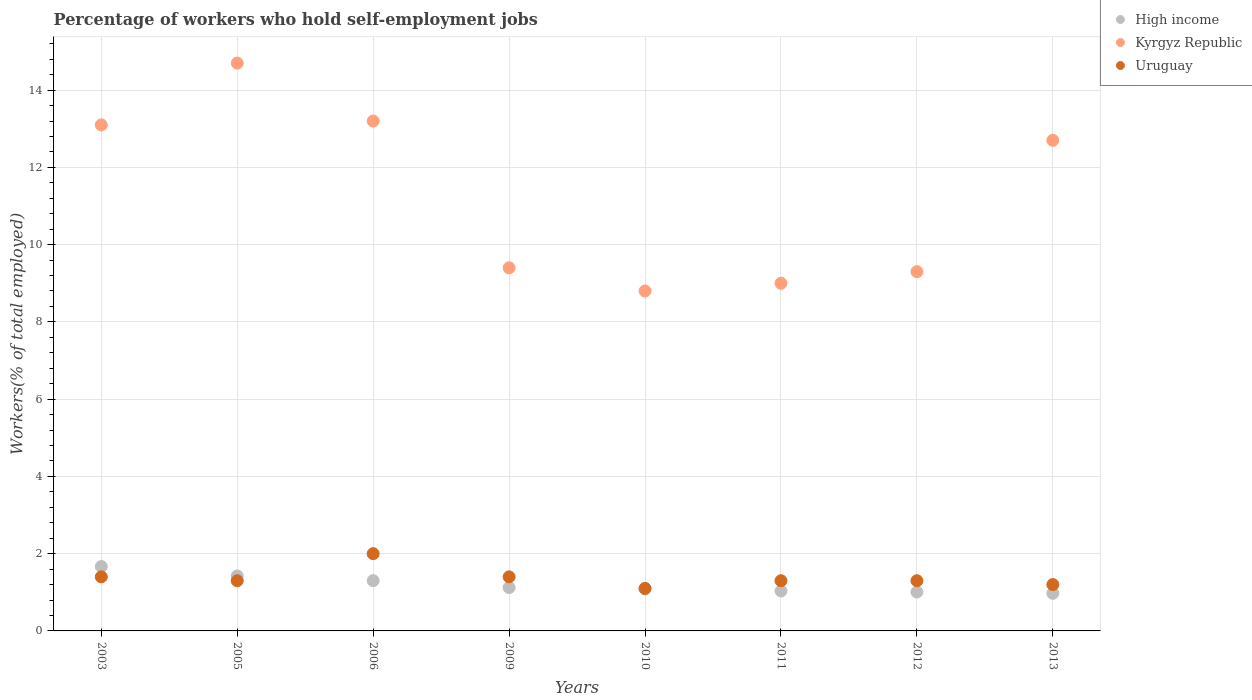Is the number of dotlines equal to the number of legend labels?
Keep it short and to the point. Yes. What is the percentage of self-employed workers in Uruguay in 2003?
Offer a very short reply. 1.4. Across all years, what is the minimum percentage of self-employed workers in Uruguay?
Ensure brevity in your answer.  1.1. In which year was the percentage of self-employed workers in Uruguay minimum?
Provide a succinct answer. 2010. What is the total percentage of self-employed workers in High income in the graph?
Your answer should be very brief. 9.62. What is the difference between the percentage of self-employed workers in Uruguay in 2010 and that in 2013?
Your answer should be very brief. -0.1. What is the difference between the percentage of self-employed workers in High income in 2013 and the percentage of self-employed workers in Kyrgyz Republic in 2010?
Keep it short and to the point. -7.83. What is the average percentage of self-employed workers in High income per year?
Give a very brief answer. 1.2. In the year 2011, what is the difference between the percentage of self-employed workers in High income and percentage of self-employed workers in Uruguay?
Provide a succinct answer. -0.27. What is the ratio of the percentage of self-employed workers in Kyrgyz Republic in 2010 to that in 2011?
Your answer should be compact. 0.98. Is the percentage of self-employed workers in High income in 2005 less than that in 2012?
Provide a short and direct response. No. What is the difference between the highest and the second highest percentage of self-employed workers in Kyrgyz Republic?
Make the answer very short. 1.5. What is the difference between the highest and the lowest percentage of self-employed workers in High income?
Provide a succinct answer. 0.69. In how many years, is the percentage of self-employed workers in Kyrgyz Republic greater than the average percentage of self-employed workers in Kyrgyz Republic taken over all years?
Provide a succinct answer. 4. Is the sum of the percentage of self-employed workers in High income in 2005 and 2012 greater than the maximum percentage of self-employed workers in Uruguay across all years?
Ensure brevity in your answer.  Yes. Is it the case that in every year, the sum of the percentage of self-employed workers in Uruguay and percentage of self-employed workers in High income  is greater than the percentage of self-employed workers in Kyrgyz Republic?
Your response must be concise. No. Does the percentage of self-employed workers in Kyrgyz Republic monotonically increase over the years?
Your answer should be very brief. No. How many dotlines are there?
Offer a very short reply. 3. What is the difference between two consecutive major ticks on the Y-axis?
Keep it short and to the point. 2. Are the values on the major ticks of Y-axis written in scientific E-notation?
Provide a short and direct response. No. Where does the legend appear in the graph?
Keep it short and to the point. Top right. How many legend labels are there?
Ensure brevity in your answer.  3. How are the legend labels stacked?
Keep it short and to the point. Vertical. What is the title of the graph?
Give a very brief answer. Percentage of workers who hold self-employment jobs. What is the label or title of the Y-axis?
Offer a terse response. Workers(% of total employed). What is the Workers(% of total employed) in High income in 2003?
Provide a succinct answer. 1.67. What is the Workers(% of total employed) of Kyrgyz Republic in 2003?
Your response must be concise. 13.1. What is the Workers(% of total employed) of Uruguay in 2003?
Provide a succinct answer. 1.4. What is the Workers(% of total employed) of High income in 2005?
Your answer should be compact. 1.42. What is the Workers(% of total employed) of Kyrgyz Republic in 2005?
Give a very brief answer. 14.7. What is the Workers(% of total employed) in Uruguay in 2005?
Offer a very short reply. 1.3. What is the Workers(% of total employed) of High income in 2006?
Offer a terse response. 1.3. What is the Workers(% of total employed) of Kyrgyz Republic in 2006?
Give a very brief answer. 13.2. What is the Workers(% of total employed) of Uruguay in 2006?
Your answer should be compact. 2. What is the Workers(% of total employed) in High income in 2009?
Give a very brief answer. 1.12. What is the Workers(% of total employed) in Kyrgyz Republic in 2009?
Provide a short and direct response. 9.4. What is the Workers(% of total employed) in Uruguay in 2009?
Make the answer very short. 1.4. What is the Workers(% of total employed) in High income in 2010?
Your response must be concise. 1.09. What is the Workers(% of total employed) in Kyrgyz Republic in 2010?
Ensure brevity in your answer.  8.8. What is the Workers(% of total employed) in Uruguay in 2010?
Make the answer very short. 1.1. What is the Workers(% of total employed) of High income in 2011?
Your response must be concise. 1.03. What is the Workers(% of total employed) in Uruguay in 2011?
Give a very brief answer. 1.3. What is the Workers(% of total employed) of High income in 2012?
Offer a terse response. 1.01. What is the Workers(% of total employed) in Kyrgyz Republic in 2012?
Keep it short and to the point. 9.3. What is the Workers(% of total employed) in Uruguay in 2012?
Provide a short and direct response. 1.3. What is the Workers(% of total employed) of High income in 2013?
Make the answer very short. 0.97. What is the Workers(% of total employed) in Kyrgyz Republic in 2013?
Offer a very short reply. 12.7. What is the Workers(% of total employed) of Uruguay in 2013?
Provide a succinct answer. 1.2. Across all years, what is the maximum Workers(% of total employed) of High income?
Keep it short and to the point. 1.67. Across all years, what is the maximum Workers(% of total employed) of Kyrgyz Republic?
Provide a short and direct response. 14.7. Across all years, what is the maximum Workers(% of total employed) of Uruguay?
Your answer should be compact. 2. Across all years, what is the minimum Workers(% of total employed) of High income?
Ensure brevity in your answer.  0.97. Across all years, what is the minimum Workers(% of total employed) in Kyrgyz Republic?
Your answer should be very brief. 8.8. Across all years, what is the minimum Workers(% of total employed) of Uruguay?
Your response must be concise. 1.1. What is the total Workers(% of total employed) of High income in the graph?
Keep it short and to the point. 9.62. What is the total Workers(% of total employed) in Kyrgyz Republic in the graph?
Ensure brevity in your answer.  90.2. What is the difference between the Workers(% of total employed) in High income in 2003 and that in 2005?
Make the answer very short. 0.24. What is the difference between the Workers(% of total employed) in Kyrgyz Republic in 2003 and that in 2005?
Your answer should be very brief. -1.6. What is the difference between the Workers(% of total employed) in Uruguay in 2003 and that in 2005?
Offer a very short reply. 0.1. What is the difference between the Workers(% of total employed) in High income in 2003 and that in 2006?
Provide a succinct answer. 0.37. What is the difference between the Workers(% of total employed) of Kyrgyz Republic in 2003 and that in 2006?
Offer a very short reply. -0.1. What is the difference between the Workers(% of total employed) of Uruguay in 2003 and that in 2006?
Your answer should be very brief. -0.6. What is the difference between the Workers(% of total employed) of High income in 2003 and that in 2009?
Your answer should be compact. 0.55. What is the difference between the Workers(% of total employed) of Kyrgyz Republic in 2003 and that in 2009?
Provide a short and direct response. 3.7. What is the difference between the Workers(% of total employed) in High income in 2003 and that in 2010?
Keep it short and to the point. 0.58. What is the difference between the Workers(% of total employed) of Kyrgyz Republic in 2003 and that in 2010?
Ensure brevity in your answer.  4.3. What is the difference between the Workers(% of total employed) of Uruguay in 2003 and that in 2010?
Give a very brief answer. 0.3. What is the difference between the Workers(% of total employed) of High income in 2003 and that in 2011?
Ensure brevity in your answer.  0.63. What is the difference between the Workers(% of total employed) of Kyrgyz Republic in 2003 and that in 2011?
Provide a succinct answer. 4.1. What is the difference between the Workers(% of total employed) in High income in 2003 and that in 2012?
Provide a short and direct response. 0.66. What is the difference between the Workers(% of total employed) in Kyrgyz Republic in 2003 and that in 2012?
Offer a terse response. 3.8. What is the difference between the Workers(% of total employed) of Uruguay in 2003 and that in 2012?
Provide a short and direct response. 0.1. What is the difference between the Workers(% of total employed) of High income in 2003 and that in 2013?
Keep it short and to the point. 0.69. What is the difference between the Workers(% of total employed) in Kyrgyz Republic in 2003 and that in 2013?
Offer a very short reply. 0.4. What is the difference between the Workers(% of total employed) in High income in 2005 and that in 2006?
Give a very brief answer. 0.12. What is the difference between the Workers(% of total employed) in High income in 2005 and that in 2009?
Give a very brief answer. 0.3. What is the difference between the Workers(% of total employed) in Uruguay in 2005 and that in 2009?
Provide a short and direct response. -0.1. What is the difference between the Workers(% of total employed) of High income in 2005 and that in 2010?
Make the answer very short. 0.33. What is the difference between the Workers(% of total employed) of Kyrgyz Republic in 2005 and that in 2010?
Give a very brief answer. 5.9. What is the difference between the Workers(% of total employed) in High income in 2005 and that in 2011?
Your answer should be very brief. 0.39. What is the difference between the Workers(% of total employed) in Uruguay in 2005 and that in 2011?
Offer a terse response. 0. What is the difference between the Workers(% of total employed) of High income in 2005 and that in 2012?
Your answer should be very brief. 0.42. What is the difference between the Workers(% of total employed) of Uruguay in 2005 and that in 2012?
Offer a very short reply. 0. What is the difference between the Workers(% of total employed) in High income in 2005 and that in 2013?
Ensure brevity in your answer.  0.45. What is the difference between the Workers(% of total employed) of Uruguay in 2005 and that in 2013?
Your answer should be compact. 0.1. What is the difference between the Workers(% of total employed) of High income in 2006 and that in 2009?
Make the answer very short. 0.18. What is the difference between the Workers(% of total employed) of Uruguay in 2006 and that in 2009?
Your answer should be very brief. 0.6. What is the difference between the Workers(% of total employed) of High income in 2006 and that in 2010?
Your response must be concise. 0.21. What is the difference between the Workers(% of total employed) of Uruguay in 2006 and that in 2010?
Ensure brevity in your answer.  0.9. What is the difference between the Workers(% of total employed) in High income in 2006 and that in 2011?
Your response must be concise. 0.27. What is the difference between the Workers(% of total employed) of High income in 2006 and that in 2012?
Provide a short and direct response. 0.29. What is the difference between the Workers(% of total employed) of High income in 2006 and that in 2013?
Your response must be concise. 0.33. What is the difference between the Workers(% of total employed) in Uruguay in 2006 and that in 2013?
Keep it short and to the point. 0.8. What is the difference between the Workers(% of total employed) in High income in 2009 and that in 2010?
Ensure brevity in your answer.  0.03. What is the difference between the Workers(% of total employed) of Kyrgyz Republic in 2009 and that in 2010?
Ensure brevity in your answer.  0.6. What is the difference between the Workers(% of total employed) in High income in 2009 and that in 2011?
Offer a very short reply. 0.09. What is the difference between the Workers(% of total employed) of High income in 2009 and that in 2012?
Your answer should be very brief. 0.11. What is the difference between the Workers(% of total employed) of Kyrgyz Republic in 2009 and that in 2012?
Keep it short and to the point. 0.1. What is the difference between the Workers(% of total employed) of High income in 2009 and that in 2013?
Your answer should be compact. 0.15. What is the difference between the Workers(% of total employed) in Kyrgyz Republic in 2009 and that in 2013?
Your answer should be compact. -3.3. What is the difference between the Workers(% of total employed) in High income in 2010 and that in 2011?
Offer a very short reply. 0.06. What is the difference between the Workers(% of total employed) of High income in 2010 and that in 2012?
Offer a very short reply. 0.08. What is the difference between the Workers(% of total employed) of Kyrgyz Republic in 2010 and that in 2012?
Your answer should be compact. -0.5. What is the difference between the Workers(% of total employed) of Uruguay in 2010 and that in 2012?
Provide a succinct answer. -0.2. What is the difference between the Workers(% of total employed) in High income in 2010 and that in 2013?
Offer a terse response. 0.12. What is the difference between the Workers(% of total employed) of High income in 2011 and that in 2012?
Offer a terse response. 0.03. What is the difference between the Workers(% of total employed) of Kyrgyz Republic in 2011 and that in 2012?
Your response must be concise. -0.3. What is the difference between the Workers(% of total employed) in Uruguay in 2011 and that in 2012?
Offer a very short reply. 0. What is the difference between the Workers(% of total employed) of High income in 2011 and that in 2013?
Your answer should be very brief. 0.06. What is the difference between the Workers(% of total employed) of High income in 2012 and that in 2013?
Your answer should be very brief. 0.03. What is the difference between the Workers(% of total employed) of High income in 2003 and the Workers(% of total employed) of Kyrgyz Republic in 2005?
Offer a very short reply. -13.03. What is the difference between the Workers(% of total employed) in High income in 2003 and the Workers(% of total employed) in Uruguay in 2005?
Ensure brevity in your answer.  0.37. What is the difference between the Workers(% of total employed) of Kyrgyz Republic in 2003 and the Workers(% of total employed) of Uruguay in 2005?
Give a very brief answer. 11.8. What is the difference between the Workers(% of total employed) in High income in 2003 and the Workers(% of total employed) in Kyrgyz Republic in 2006?
Provide a short and direct response. -11.53. What is the difference between the Workers(% of total employed) of High income in 2003 and the Workers(% of total employed) of Uruguay in 2006?
Ensure brevity in your answer.  -0.33. What is the difference between the Workers(% of total employed) of Kyrgyz Republic in 2003 and the Workers(% of total employed) of Uruguay in 2006?
Keep it short and to the point. 11.1. What is the difference between the Workers(% of total employed) of High income in 2003 and the Workers(% of total employed) of Kyrgyz Republic in 2009?
Keep it short and to the point. -7.73. What is the difference between the Workers(% of total employed) of High income in 2003 and the Workers(% of total employed) of Uruguay in 2009?
Keep it short and to the point. 0.27. What is the difference between the Workers(% of total employed) of High income in 2003 and the Workers(% of total employed) of Kyrgyz Republic in 2010?
Give a very brief answer. -7.13. What is the difference between the Workers(% of total employed) in High income in 2003 and the Workers(% of total employed) in Uruguay in 2010?
Keep it short and to the point. 0.57. What is the difference between the Workers(% of total employed) in Kyrgyz Republic in 2003 and the Workers(% of total employed) in Uruguay in 2010?
Your response must be concise. 12. What is the difference between the Workers(% of total employed) in High income in 2003 and the Workers(% of total employed) in Kyrgyz Republic in 2011?
Offer a very short reply. -7.33. What is the difference between the Workers(% of total employed) in High income in 2003 and the Workers(% of total employed) in Uruguay in 2011?
Offer a very short reply. 0.37. What is the difference between the Workers(% of total employed) in Kyrgyz Republic in 2003 and the Workers(% of total employed) in Uruguay in 2011?
Ensure brevity in your answer.  11.8. What is the difference between the Workers(% of total employed) of High income in 2003 and the Workers(% of total employed) of Kyrgyz Republic in 2012?
Your answer should be very brief. -7.63. What is the difference between the Workers(% of total employed) in High income in 2003 and the Workers(% of total employed) in Uruguay in 2012?
Provide a succinct answer. 0.37. What is the difference between the Workers(% of total employed) of High income in 2003 and the Workers(% of total employed) of Kyrgyz Republic in 2013?
Your response must be concise. -11.03. What is the difference between the Workers(% of total employed) in High income in 2003 and the Workers(% of total employed) in Uruguay in 2013?
Provide a succinct answer. 0.47. What is the difference between the Workers(% of total employed) of High income in 2005 and the Workers(% of total employed) of Kyrgyz Republic in 2006?
Your answer should be compact. -11.78. What is the difference between the Workers(% of total employed) of High income in 2005 and the Workers(% of total employed) of Uruguay in 2006?
Your answer should be very brief. -0.58. What is the difference between the Workers(% of total employed) of Kyrgyz Republic in 2005 and the Workers(% of total employed) of Uruguay in 2006?
Give a very brief answer. 12.7. What is the difference between the Workers(% of total employed) of High income in 2005 and the Workers(% of total employed) of Kyrgyz Republic in 2009?
Give a very brief answer. -7.98. What is the difference between the Workers(% of total employed) in High income in 2005 and the Workers(% of total employed) in Uruguay in 2009?
Offer a terse response. 0.02. What is the difference between the Workers(% of total employed) of High income in 2005 and the Workers(% of total employed) of Kyrgyz Republic in 2010?
Your answer should be very brief. -7.38. What is the difference between the Workers(% of total employed) in High income in 2005 and the Workers(% of total employed) in Uruguay in 2010?
Provide a succinct answer. 0.32. What is the difference between the Workers(% of total employed) of High income in 2005 and the Workers(% of total employed) of Kyrgyz Republic in 2011?
Provide a succinct answer. -7.58. What is the difference between the Workers(% of total employed) of High income in 2005 and the Workers(% of total employed) of Uruguay in 2011?
Offer a terse response. 0.12. What is the difference between the Workers(% of total employed) in Kyrgyz Republic in 2005 and the Workers(% of total employed) in Uruguay in 2011?
Your response must be concise. 13.4. What is the difference between the Workers(% of total employed) of High income in 2005 and the Workers(% of total employed) of Kyrgyz Republic in 2012?
Provide a succinct answer. -7.88. What is the difference between the Workers(% of total employed) of High income in 2005 and the Workers(% of total employed) of Uruguay in 2012?
Your response must be concise. 0.12. What is the difference between the Workers(% of total employed) of Kyrgyz Republic in 2005 and the Workers(% of total employed) of Uruguay in 2012?
Offer a very short reply. 13.4. What is the difference between the Workers(% of total employed) in High income in 2005 and the Workers(% of total employed) in Kyrgyz Republic in 2013?
Your response must be concise. -11.28. What is the difference between the Workers(% of total employed) in High income in 2005 and the Workers(% of total employed) in Uruguay in 2013?
Your answer should be compact. 0.22. What is the difference between the Workers(% of total employed) in High income in 2006 and the Workers(% of total employed) in Kyrgyz Republic in 2009?
Give a very brief answer. -8.1. What is the difference between the Workers(% of total employed) in High income in 2006 and the Workers(% of total employed) in Uruguay in 2009?
Keep it short and to the point. -0.1. What is the difference between the Workers(% of total employed) of High income in 2006 and the Workers(% of total employed) of Kyrgyz Republic in 2010?
Provide a short and direct response. -7.5. What is the difference between the Workers(% of total employed) in High income in 2006 and the Workers(% of total employed) in Uruguay in 2010?
Give a very brief answer. 0.2. What is the difference between the Workers(% of total employed) of High income in 2006 and the Workers(% of total employed) of Kyrgyz Republic in 2011?
Give a very brief answer. -7.7. What is the difference between the Workers(% of total employed) in High income in 2006 and the Workers(% of total employed) in Uruguay in 2011?
Provide a succinct answer. 0. What is the difference between the Workers(% of total employed) in High income in 2006 and the Workers(% of total employed) in Kyrgyz Republic in 2012?
Offer a very short reply. -8. What is the difference between the Workers(% of total employed) in High income in 2006 and the Workers(% of total employed) in Uruguay in 2012?
Offer a very short reply. 0. What is the difference between the Workers(% of total employed) of High income in 2006 and the Workers(% of total employed) of Kyrgyz Republic in 2013?
Provide a short and direct response. -11.4. What is the difference between the Workers(% of total employed) in High income in 2006 and the Workers(% of total employed) in Uruguay in 2013?
Keep it short and to the point. 0.1. What is the difference between the Workers(% of total employed) in High income in 2009 and the Workers(% of total employed) in Kyrgyz Republic in 2010?
Offer a very short reply. -7.68. What is the difference between the Workers(% of total employed) of High income in 2009 and the Workers(% of total employed) of Uruguay in 2010?
Provide a succinct answer. 0.02. What is the difference between the Workers(% of total employed) in Kyrgyz Republic in 2009 and the Workers(% of total employed) in Uruguay in 2010?
Keep it short and to the point. 8.3. What is the difference between the Workers(% of total employed) in High income in 2009 and the Workers(% of total employed) in Kyrgyz Republic in 2011?
Your answer should be very brief. -7.88. What is the difference between the Workers(% of total employed) of High income in 2009 and the Workers(% of total employed) of Uruguay in 2011?
Give a very brief answer. -0.18. What is the difference between the Workers(% of total employed) in High income in 2009 and the Workers(% of total employed) in Kyrgyz Republic in 2012?
Offer a very short reply. -8.18. What is the difference between the Workers(% of total employed) of High income in 2009 and the Workers(% of total employed) of Uruguay in 2012?
Offer a terse response. -0.18. What is the difference between the Workers(% of total employed) in Kyrgyz Republic in 2009 and the Workers(% of total employed) in Uruguay in 2012?
Keep it short and to the point. 8.1. What is the difference between the Workers(% of total employed) in High income in 2009 and the Workers(% of total employed) in Kyrgyz Republic in 2013?
Offer a very short reply. -11.58. What is the difference between the Workers(% of total employed) in High income in 2009 and the Workers(% of total employed) in Uruguay in 2013?
Give a very brief answer. -0.08. What is the difference between the Workers(% of total employed) of Kyrgyz Republic in 2009 and the Workers(% of total employed) of Uruguay in 2013?
Make the answer very short. 8.2. What is the difference between the Workers(% of total employed) in High income in 2010 and the Workers(% of total employed) in Kyrgyz Republic in 2011?
Your response must be concise. -7.91. What is the difference between the Workers(% of total employed) of High income in 2010 and the Workers(% of total employed) of Uruguay in 2011?
Your answer should be very brief. -0.21. What is the difference between the Workers(% of total employed) in High income in 2010 and the Workers(% of total employed) in Kyrgyz Republic in 2012?
Offer a very short reply. -8.21. What is the difference between the Workers(% of total employed) in High income in 2010 and the Workers(% of total employed) in Uruguay in 2012?
Give a very brief answer. -0.21. What is the difference between the Workers(% of total employed) of Kyrgyz Republic in 2010 and the Workers(% of total employed) of Uruguay in 2012?
Provide a short and direct response. 7.5. What is the difference between the Workers(% of total employed) in High income in 2010 and the Workers(% of total employed) in Kyrgyz Republic in 2013?
Ensure brevity in your answer.  -11.61. What is the difference between the Workers(% of total employed) of High income in 2010 and the Workers(% of total employed) of Uruguay in 2013?
Give a very brief answer. -0.11. What is the difference between the Workers(% of total employed) in Kyrgyz Republic in 2010 and the Workers(% of total employed) in Uruguay in 2013?
Provide a short and direct response. 7.6. What is the difference between the Workers(% of total employed) in High income in 2011 and the Workers(% of total employed) in Kyrgyz Republic in 2012?
Offer a very short reply. -8.27. What is the difference between the Workers(% of total employed) of High income in 2011 and the Workers(% of total employed) of Uruguay in 2012?
Offer a terse response. -0.27. What is the difference between the Workers(% of total employed) in Kyrgyz Republic in 2011 and the Workers(% of total employed) in Uruguay in 2012?
Give a very brief answer. 7.7. What is the difference between the Workers(% of total employed) in High income in 2011 and the Workers(% of total employed) in Kyrgyz Republic in 2013?
Ensure brevity in your answer.  -11.67. What is the difference between the Workers(% of total employed) of Kyrgyz Republic in 2011 and the Workers(% of total employed) of Uruguay in 2013?
Your answer should be compact. 7.8. What is the difference between the Workers(% of total employed) in High income in 2012 and the Workers(% of total employed) in Kyrgyz Republic in 2013?
Make the answer very short. -11.69. What is the difference between the Workers(% of total employed) of High income in 2012 and the Workers(% of total employed) of Uruguay in 2013?
Make the answer very short. -0.19. What is the difference between the Workers(% of total employed) of Kyrgyz Republic in 2012 and the Workers(% of total employed) of Uruguay in 2013?
Your response must be concise. 8.1. What is the average Workers(% of total employed) of High income per year?
Your answer should be compact. 1.2. What is the average Workers(% of total employed) of Kyrgyz Republic per year?
Make the answer very short. 11.28. What is the average Workers(% of total employed) in Uruguay per year?
Offer a terse response. 1.38. In the year 2003, what is the difference between the Workers(% of total employed) in High income and Workers(% of total employed) in Kyrgyz Republic?
Your response must be concise. -11.43. In the year 2003, what is the difference between the Workers(% of total employed) of High income and Workers(% of total employed) of Uruguay?
Give a very brief answer. 0.27. In the year 2005, what is the difference between the Workers(% of total employed) in High income and Workers(% of total employed) in Kyrgyz Republic?
Offer a very short reply. -13.28. In the year 2005, what is the difference between the Workers(% of total employed) of High income and Workers(% of total employed) of Uruguay?
Your response must be concise. 0.12. In the year 2006, what is the difference between the Workers(% of total employed) in High income and Workers(% of total employed) in Kyrgyz Republic?
Your answer should be compact. -11.9. In the year 2006, what is the difference between the Workers(% of total employed) in High income and Workers(% of total employed) in Uruguay?
Your response must be concise. -0.7. In the year 2006, what is the difference between the Workers(% of total employed) of Kyrgyz Republic and Workers(% of total employed) of Uruguay?
Provide a succinct answer. 11.2. In the year 2009, what is the difference between the Workers(% of total employed) of High income and Workers(% of total employed) of Kyrgyz Republic?
Keep it short and to the point. -8.28. In the year 2009, what is the difference between the Workers(% of total employed) of High income and Workers(% of total employed) of Uruguay?
Your answer should be very brief. -0.28. In the year 2009, what is the difference between the Workers(% of total employed) in Kyrgyz Republic and Workers(% of total employed) in Uruguay?
Offer a very short reply. 8. In the year 2010, what is the difference between the Workers(% of total employed) of High income and Workers(% of total employed) of Kyrgyz Republic?
Your answer should be compact. -7.71. In the year 2010, what is the difference between the Workers(% of total employed) of High income and Workers(% of total employed) of Uruguay?
Make the answer very short. -0.01. In the year 2011, what is the difference between the Workers(% of total employed) in High income and Workers(% of total employed) in Kyrgyz Republic?
Your response must be concise. -7.97. In the year 2011, what is the difference between the Workers(% of total employed) of High income and Workers(% of total employed) of Uruguay?
Your answer should be very brief. -0.27. In the year 2012, what is the difference between the Workers(% of total employed) of High income and Workers(% of total employed) of Kyrgyz Republic?
Your answer should be very brief. -8.29. In the year 2012, what is the difference between the Workers(% of total employed) in High income and Workers(% of total employed) in Uruguay?
Ensure brevity in your answer.  -0.29. In the year 2013, what is the difference between the Workers(% of total employed) in High income and Workers(% of total employed) in Kyrgyz Republic?
Ensure brevity in your answer.  -11.73. In the year 2013, what is the difference between the Workers(% of total employed) in High income and Workers(% of total employed) in Uruguay?
Ensure brevity in your answer.  -0.23. What is the ratio of the Workers(% of total employed) of High income in 2003 to that in 2005?
Your answer should be compact. 1.17. What is the ratio of the Workers(% of total employed) of Kyrgyz Republic in 2003 to that in 2005?
Your answer should be very brief. 0.89. What is the ratio of the Workers(% of total employed) in Uruguay in 2003 to that in 2005?
Give a very brief answer. 1.08. What is the ratio of the Workers(% of total employed) of High income in 2003 to that in 2006?
Provide a short and direct response. 1.28. What is the ratio of the Workers(% of total employed) in Kyrgyz Republic in 2003 to that in 2006?
Ensure brevity in your answer.  0.99. What is the ratio of the Workers(% of total employed) of Uruguay in 2003 to that in 2006?
Give a very brief answer. 0.7. What is the ratio of the Workers(% of total employed) in High income in 2003 to that in 2009?
Your answer should be very brief. 1.49. What is the ratio of the Workers(% of total employed) of Kyrgyz Republic in 2003 to that in 2009?
Offer a very short reply. 1.39. What is the ratio of the Workers(% of total employed) in Uruguay in 2003 to that in 2009?
Offer a terse response. 1. What is the ratio of the Workers(% of total employed) in High income in 2003 to that in 2010?
Offer a terse response. 1.53. What is the ratio of the Workers(% of total employed) in Kyrgyz Republic in 2003 to that in 2010?
Make the answer very short. 1.49. What is the ratio of the Workers(% of total employed) in Uruguay in 2003 to that in 2010?
Your response must be concise. 1.27. What is the ratio of the Workers(% of total employed) in High income in 2003 to that in 2011?
Ensure brevity in your answer.  1.61. What is the ratio of the Workers(% of total employed) in Kyrgyz Republic in 2003 to that in 2011?
Your answer should be very brief. 1.46. What is the ratio of the Workers(% of total employed) in High income in 2003 to that in 2012?
Provide a succinct answer. 1.66. What is the ratio of the Workers(% of total employed) of Kyrgyz Republic in 2003 to that in 2012?
Your response must be concise. 1.41. What is the ratio of the Workers(% of total employed) in Uruguay in 2003 to that in 2012?
Ensure brevity in your answer.  1.08. What is the ratio of the Workers(% of total employed) in High income in 2003 to that in 2013?
Keep it short and to the point. 1.71. What is the ratio of the Workers(% of total employed) in Kyrgyz Republic in 2003 to that in 2013?
Give a very brief answer. 1.03. What is the ratio of the Workers(% of total employed) of High income in 2005 to that in 2006?
Provide a succinct answer. 1.09. What is the ratio of the Workers(% of total employed) in Kyrgyz Republic in 2005 to that in 2006?
Your answer should be compact. 1.11. What is the ratio of the Workers(% of total employed) in Uruguay in 2005 to that in 2006?
Your response must be concise. 0.65. What is the ratio of the Workers(% of total employed) of High income in 2005 to that in 2009?
Offer a very short reply. 1.27. What is the ratio of the Workers(% of total employed) of Kyrgyz Republic in 2005 to that in 2009?
Provide a succinct answer. 1.56. What is the ratio of the Workers(% of total employed) of Uruguay in 2005 to that in 2009?
Provide a succinct answer. 0.93. What is the ratio of the Workers(% of total employed) in High income in 2005 to that in 2010?
Your response must be concise. 1.31. What is the ratio of the Workers(% of total employed) of Kyrgyz Republic in 2005 to that in 2010?
Your answer should be compact. 1.67. What is the ratio of the Workers(% of total employed) in Uruguay in 2005 to that in 2010?
Offer a very short reply. 1.18. What is the ratio of the Workers(% of total employed) of High income in 2005 to that in 2011?
Your answer should be compact. 1.38. What is the ratio of the Workers(% of total employed) in Kyrgyz Republic in 2005 to that in 2011?
Ensure brevity in your answer.  1.63. What is the ratio of the Workers(% of total employed) of High income in 2005 to that in 2012?
Offer a terse response. 1.41. What is the ratio of the Workers(% of total employed) in Kyrgyz Republic in 2005 to that in 2012?
Provide a short and direct response. 1.58. What is the ratio of the Workers(% of total employed) in High income in 2005 to that in 2013?
Your response must be concise. 1.46. What is the ratio of the Workers(% of total employed) in Kyrgyz Republic in 2005 to that in 2013?
Keep it short and to the point. 1.16. What is the ratio of the Workers(% of total employed) of High income in 2006 to that in 2009?
Ensure brevity in your answer.  1.16. What is the ratio of the Workers(% of total employed) in Kyrgyz Republic in 2006 to that in 2009?
Provide a short and direct response. 1.4. What is the ratio of the Workers(% of total employed) in Uruguay in 2006 to that in 2009?
Give a very brief answer. 1.43. What is the ratio of the Workers(% of total employed) in High income in 2006 to that in 2010?
Ensure brevity in your answer.  1.19. What is the ratio of the Workers(% of total employed) of Kyrgyz Republic in 2006 to that in 2010?
Ensure brevity in your answer.  1.5. What is the ratio of the Workers(% of total employed) of Uruguay in 2006 to that in 2010?
Your answer should be very brief. 1.82. What is the ratio of the Workers(% of total employed) of High income in 2006 to that in 2011?
Your answer should be very brief. 1.26. What is the ratio of the Workers(% of total employed) in Kyrgyz Republic in 2006 to that in 2011?
Keep it short and to the point. 1.47. What is the ratio of the Workers(% of total employed) in Uruguay in 2006 to that in 2011?
Provide a succinct answer. 1.54. What is the ratio of the Workers(% of total employed) in High income in 2006 to that in 2012?
Give a very brief answer. 1.29. What is the ratio of the Workers(% of total employed) of Kyrgyz Republic in 2006 to that in 2012?
Ensure brevity in your answer.  1.42. What is the ratio of the Workers(% of total employed) of Uruguay in 2006 to that in 2012?
Give a very brief answer. 1.54. What is the ratio of the Workers(% of total employed) of High income in 2006 to that in 2013?
Your answer should be compact. 1.34. What is the ratio of the Workers(% of total employed) of Kyrgyz Republic in 2006 to that in 2013?
Ensure brevity in your answer.  1.04. What is the ratio of the Workers(% of total employed) in Uruguay in 2006 to that in 2013?
Offer a very short reply. 1.67. What is the ratio of the Workers(% of total employed) in High income in 2009 to that in 2010?
Your answer should be very brief. 1.03. What is the ratio of the Workers(% of total employed) of Kyrgyz Republic in 2009 to that in 2010?
Offer a terse response. 1.07. What is the ratio of the Workers(% of total employed) of Uruguay in 2009 to that in 2010?
Your answer should be very brief. 1.27. What is the ratio of the Workers(% of total employed) of High income in 2009 to that in 2011?
Keep it short and to the point. 1.09. What is the ratio of the Workers(% of total employed) of Kyrgyz Republic in 2009 to that in 2011?
Your response must be concise. 1.04. What is the ratio of the Workers(% of total employed) of High income in 2009 to that in 2012?
Provide a succinct answer. 1.11. What is the ratio of the Workers(% of total employed) of Kyrgyz Republic in 2009 to that in 2012?
Provide a short and direct response. 1.01. What is the ratio of the Workers(% of total employed) in High income in 2009 to that in 2013?
Give a very brief answer. 1.15. What is the ratio of the Workers(% of total employed) of Kyrgyz Republic in 2009 to that in 2013?
Give a very brief answer. 0.74. What is the ratio of the Workers(% of total employed) in Uruguay in 2009 to that in 2013?
Offer a terse response. 1.17. What is the ratio of the Workers(% of total employed) of High income in 2010 to that in 2011?
Keep it short and to the point. 1.06. What is the ratio of the Workers(% of total employed) of Kyrgyz Republic in 2010 to that in 2011?
Offer a very short reply. 0.98. What is the ratio of the Workers(% of total employed) of Uruguay in 2010 to that in 2011?
Ensure brevity in your answer.  0.85. What is the ratio of the Workers(% of total employed) in High income in 2010 to that in 2012?
Make the answer very short. 1.08. What is the ratio of the Workers(% of total employed) in Kyrgyz Republic in 2010 to that in 2012?
Your answer should be compact. 0.95. What is the ratio of the Workers(% of total employed) of Uruguay in 2010 to that in 2012?
Offer a very short reply. 0.85. What is the ratio of the Workers(% of total employed) of High income in 2010 to that in 2013?
Provide a short and direct response. 1.12. What is the ratio of the Workers(% of total employed) in Kyrgyz Republic in 2010 to that in 2013?
Your answer should be very brief. 0.69. What is the ratio of the Workers(% of total employed) in High income in 2011 to that in 2012?
Ensure brevity in your answer.  1.03. What is the ratio of the Workers(% of total employed) in High income in 2011 to that in 2013?
Provide a short and direct response. 1.06. What is the ratio of the Workers(% of total employed) of Kyrgyz Republic in 2011 to that in 2013?
Make the answer very short. 0.71. What is the ratio of the Workers(% of total employed) in High income in 2012 to that in 2013?
Offer a very short reply. 1.04. What is the ratio of the Workers(% of total employed) of Kyrgyz Republic in 2012 to that in 2013?
Your answer should be compact. 0.73. What is the ratio of the Workers(% of total employed) of Uruguay in 2012 to that in 2013?
Provide a succinct answer. 1.08. What is the difference between the highest and the second highest Workers(% of total employed) in High income?
Offer a terse response. 0.24. What is the difference between the highest and the second highest Workers(% of total employed) of Kyrgyz Republic?
Give a very brief answer. 1.5. What is the difference between the highest and the lowest Workers(% of total employed) in High income?
Your answer should be compact. 0.69. 